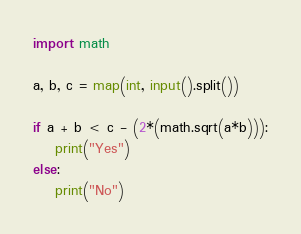<code> <loc_0><loc_0><loc_500><loc_500><_Python_>import math

a, b, c = map(int, input().split())

if a + b < c - (2*(math.sqrt(a*b))):
    print("Yes")
else:
    print("No")
</code> 